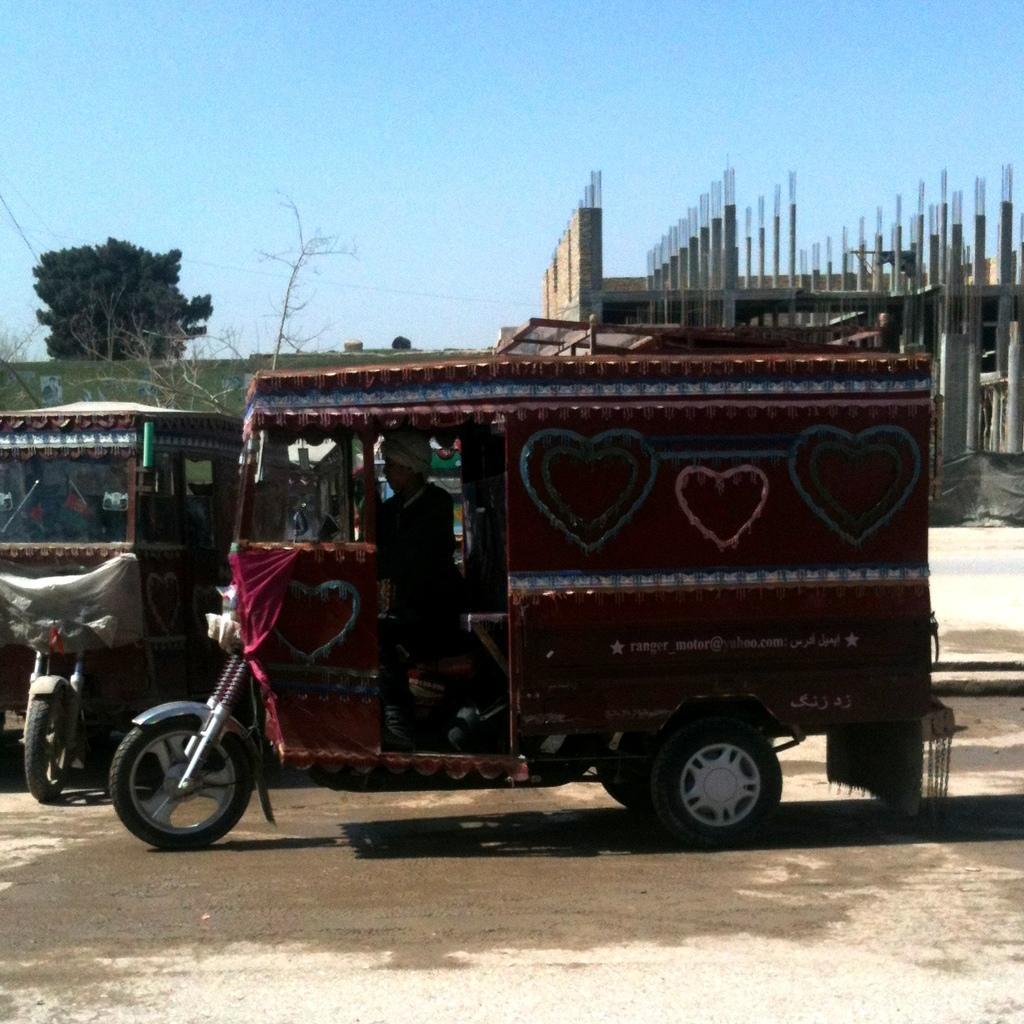Can you describe this image briefly? In this picture, we can see a few vehicles, road, peoples, and we can see construction of building, we can see trees, and the sky. 